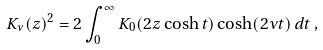<formula> <loc_0><loc_0><loc_500><loc_500>K _ { \nu } ( z ) ^ { 2 } = 2 \int _ { 0 } ^ { \infty } K _ { 0 } ( 2 z \cosh t ) \cosh ( 2 \nu t ) \, d t \, ,</formula> 